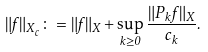<formula> <loc_0><loc_0><loc_500><loc_500>\| f \| _ { X _ { c } } \colon = \| f \| _ { X } + \sup _ { k \geq 0 } \frac { \| P _ { k } f \| _ { X } } { c _ { k } } .</formula> 